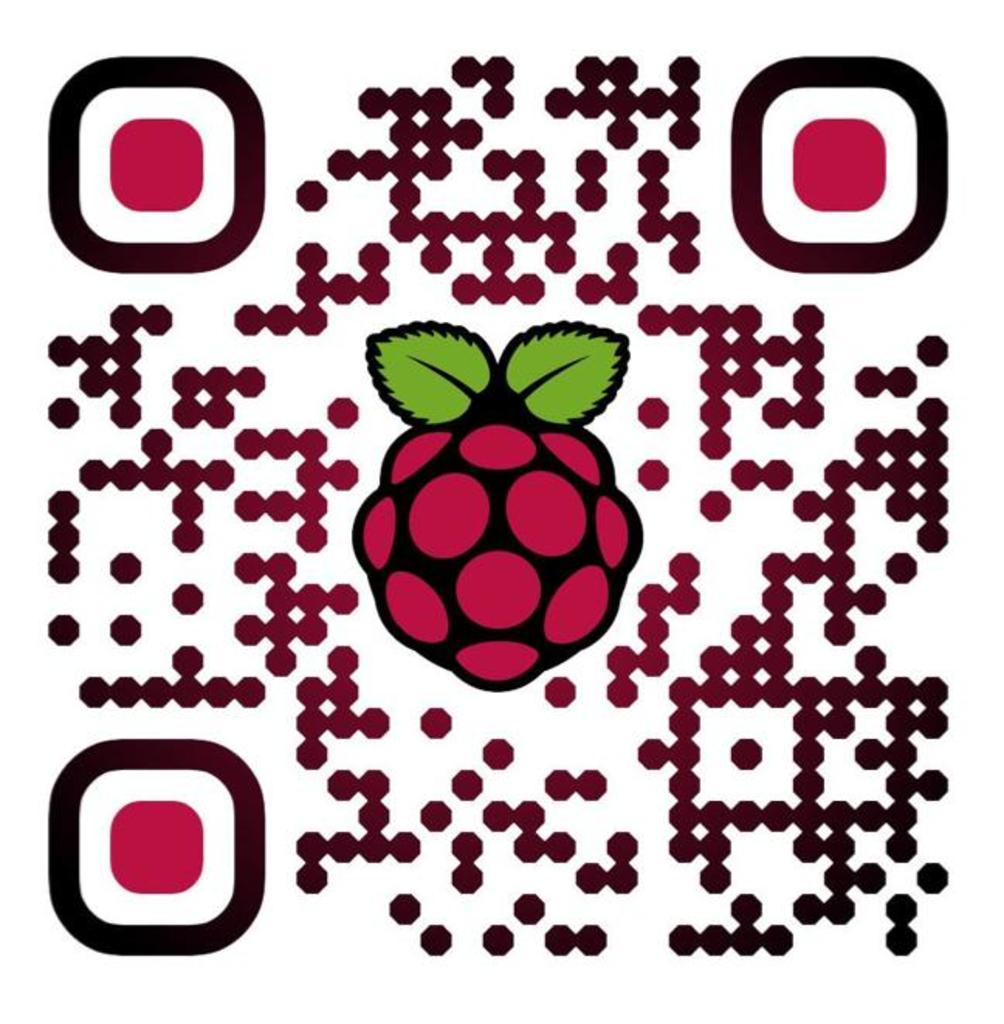What is the main feature of the image? There is a QR code in the image. What is unique about this QR code? There is fruit in the center of the QR code. How many steps are visible in the image? There are no steps visible in the image. 